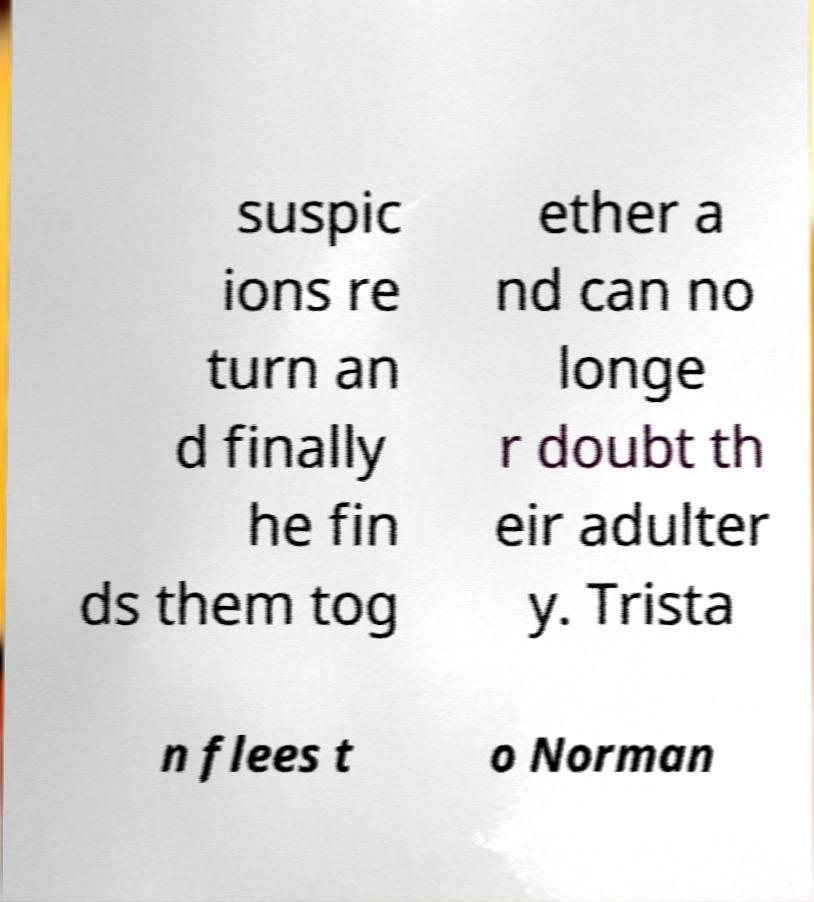Can you accurately transcribe the text from the provided image for me? suspic ions re turn an d finally he fin ds them tog ether a nd can no longe r doubt th eir adulter y. Trista n flees t o Norman 